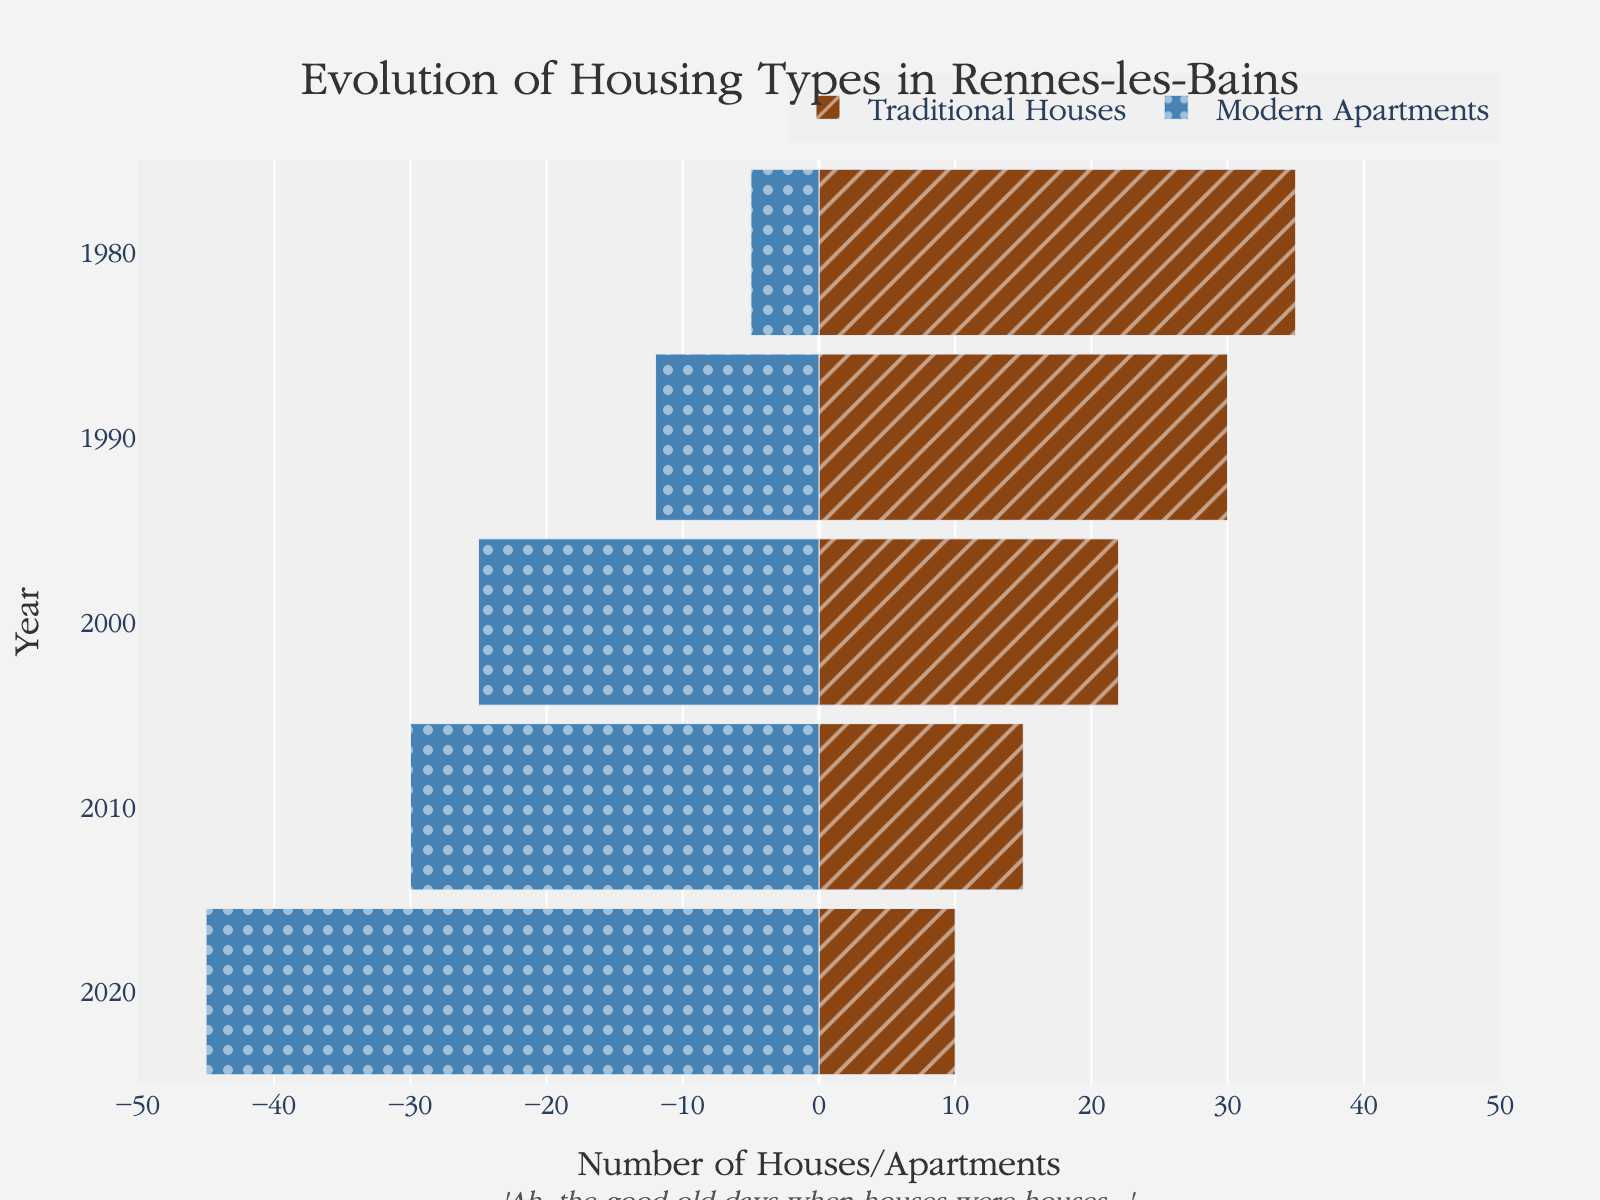What was the largest number of traditional houses recorded? By looking at the longest bar on the positive side (representing traditional houses) in the chart, we see it corresponds to 35 houses in 1980.
Answer: 35 What is the overall trend seen for modern apartments over the years? Observing the lengths of the bars on the negative side (representing modern apartments), we notice they increase progressively from 1980 (with 5 apartments) to 2020 (with 45 apartments).
Answer: Increasing How many more modern apartments were there compared to traditional houses in 2020? In 2020, there were 45 modern apartments and 10 traditional houses. The difference is 45 - 10 = 35.
Answer: 35 In which year did modern apartments surpass traditional houses? By comparing the bar lengths, modern apartments surpass traditional houses for the first time in 2000, with 25 modern apartments against just 22 traditional houses.
Answer: 2000 By how much did the number of traditional houses decrease from 1980 to 2020? The number of traditional houses in 1980 was 35 and in 2020 it was 10. The decrease is 35 - 10 = 25.
Answer: 25 What is the average number of modern apartments from 1980 to 2020? Adding the number of modern apartments for each year (5 + 12 + 25 + 30 + 45) and dividing by the number of years (5) gives (117/5).
Answer: 23.4 Which year saw the largest single-year decrease in traditional houses? By comparing the bars for traditional houses year by year, the largest decrease is from 1990 to 2000 where it drops from 30 to 22. The reduction is 30 - 22 = 8.
Answer: 2000 Were there any years when the number of traditional houses and modern apartments were equal? By examining the bar lengths, there is no year where the length of the bars for traditional houses and modern apartments match.
Answer: No Which housing type had a larger quantity in 1990? In 1990, traditional houses had a bar length of 30, while modern apartments had a bar length of 12.
Answer: Traditional Houses 